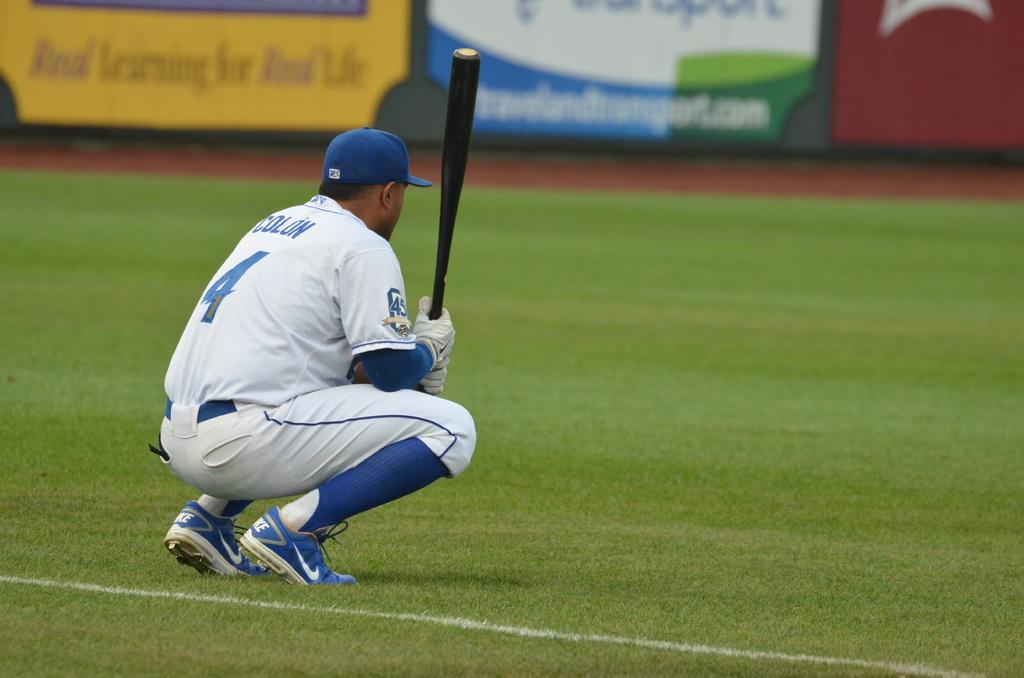<image>
Render a clear and concise summary of the photo. baseball player number 4 crouching down on the field 